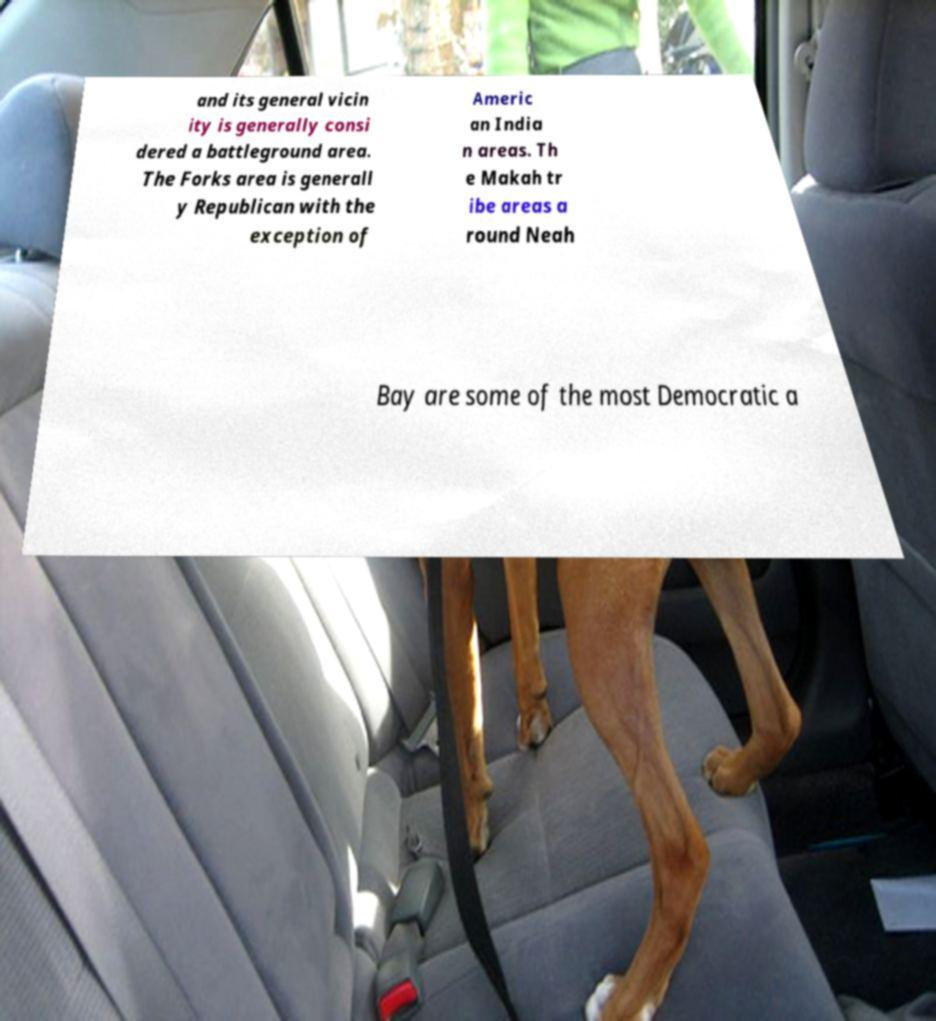Can you accurately transcribe the text from the provided image for me? and its general vicin ity is generally consi dered a battleground area. The Forks area is generall y Republican with the exception of Americ an India n areas. Th e Makah tr ibe areas a round Neah Bay are some of the most Democratic a 